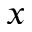<formula> <loc_0><loc_0><loc_500><loc_500>x</formula> 